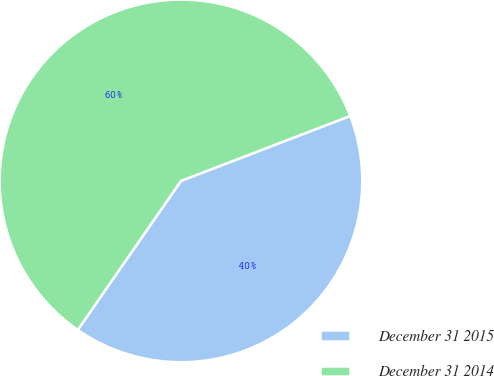Convert chart. <chart><loc_0><loc_0><loc_500><loc_500><pie_chart><fcel>December 31 2015<fcel>December 31 2014<nl><fcel>40.48%<fcel>59.52%<nl></chart> 